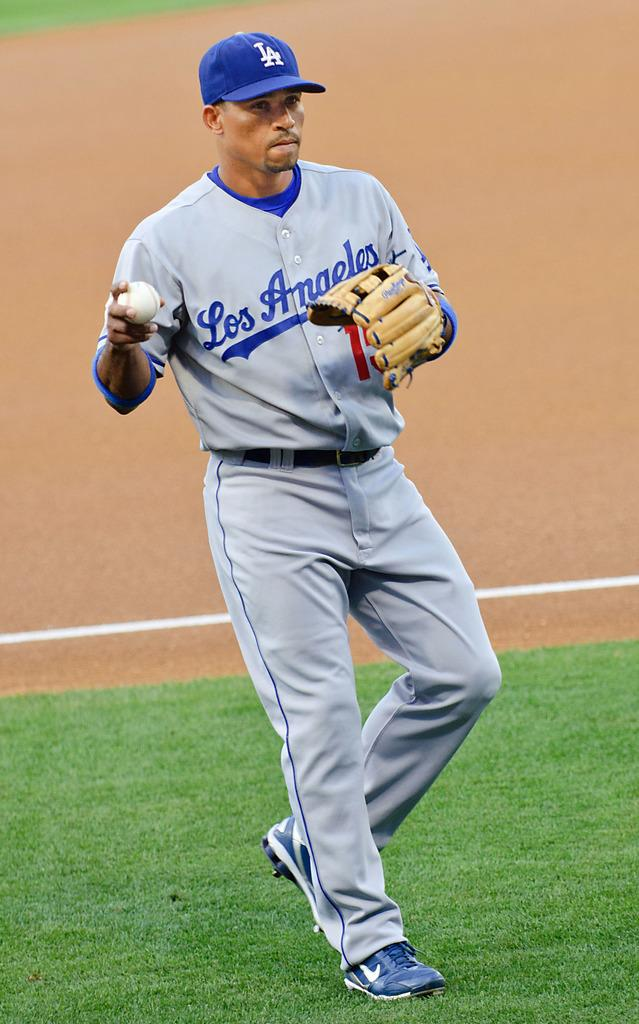Provide a one-sentence caption for the provided image. A Los Angeles baseball player getting ready to throw the ball. 